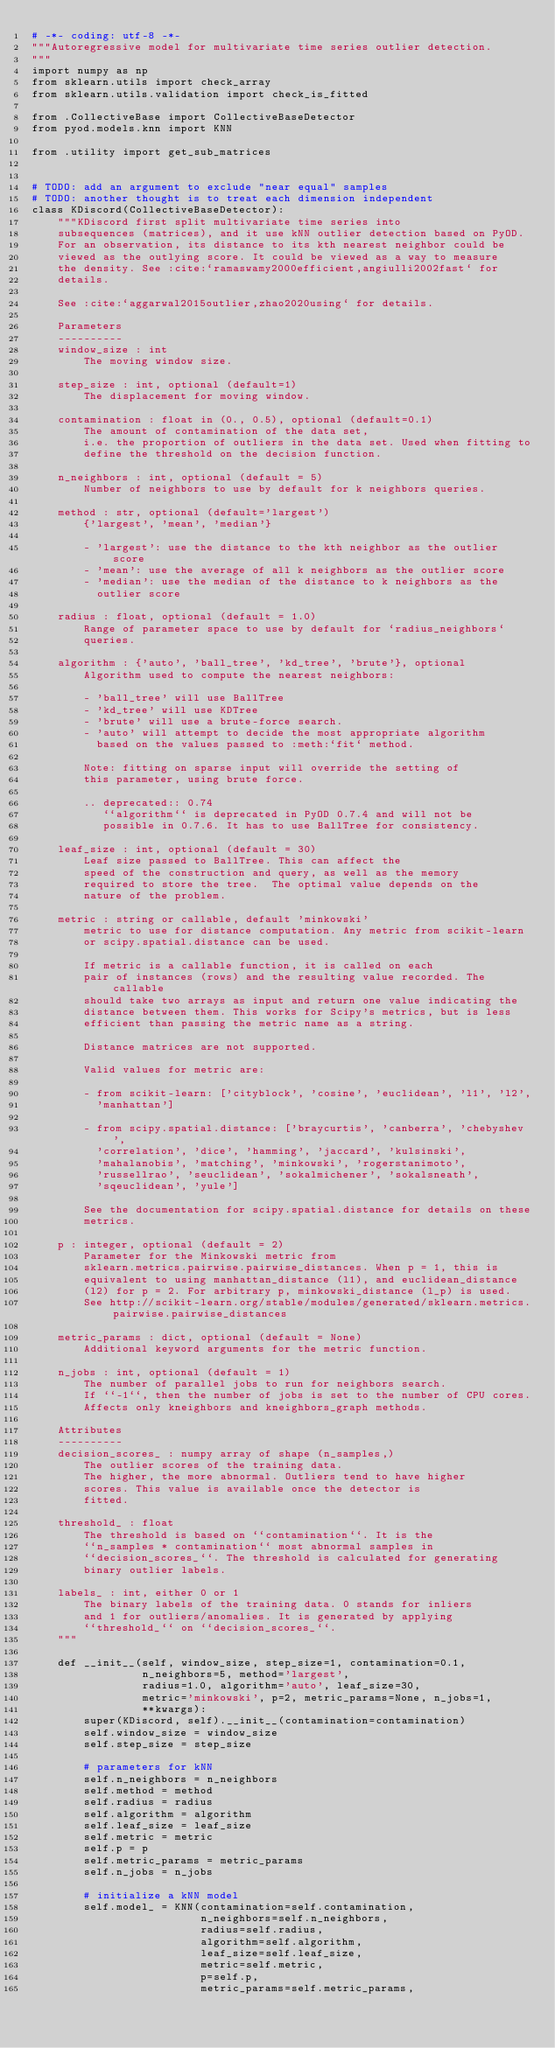Convert code to text. <code><loc_0><loc_0><loc_500><loc_500><_Python_># -*- coding: utf-8 -*-
"""Autoregressive model for multivariate time series outlier detection.
"""
import numpy as np
from sklearn.utils import check_array
from sklearn.utils.validation import check_is_fitted

from .CollectiveBase import CollectiveBaseDetector
from pyod.models.knn import KNN

from .utility import get_sub_matrices


# TODO: add an argument to exclude "near equal" samples
# TODO: another thought is to treat each dimension independent
class KDiscord(CollectiveBaseDetector):
    """KDiscord first split multivariate time series into 
    subsequences (matrices), and it use kNN outlier detection based on PyOD.
    For an observation, its distance to its kth nearest neighbor could be
    viewed as the outlying score. It could be viewed as a way to measure
    the density. See :cite:`ramaswamy2000efficient,angiulli2002fast` for
    details.
    
    See :cite:`aggarwal2015outlier,zhao2020using` for details.

    Parameters
    ----------
    window_size : int
        The moving window size.

    step_size : int, optional (default=1)
        The displacement for moving window.

    contamination : float in (0., 0.5), optional (default=0.1)
        The amount of contamination of the data set,
        i.e. the proportion of outliers in the data set. Used when fitting to
        define the threshold on the decision function.

    n_neighbors : int, optional (default = 5)
        Number of neighbors to use by default for k neighbors queries.

    method : str, optional (default='largest')
        {'largest', 'mean', 'median'}

        - 'largest': use the distance to the kth neighbor as the outlier score
        - 'mean': use the average of all k neighbors as the outlier score
        - 'median': use the median of the distance to k neighbors as the
          outlier score

    radius : float, optional (default = 1.0)
        Range of parameter space to use by default for `radius_neighbors`
        queries.

    algorithm : {'auto', 'ball_tree', 'kd_tree', 'brute'}, optional
        Algorithm used to compute the nearest neighbors:

        - 'ball_tree' will use BallTree
        - 'kd_tree' will use KDTree
        - 'brute' will use a brute-force search.
        - 'auto' will attempt to decide the most appropriate algorithm
          based on the values passed to :meth:`fit` method.

        Note: fitting on sparse input will override the setting of
        this parameter, using brute force.

        .. deprecated:: 0.74
           ``algorithm`` is deprecated in PyOD 0.7.4 and will not be
           possible in 0.7.6. It has to use BallTree for consistency.

    leaf_size : int, optional (default = 30)
        Leaf size passed to BallTree. This can affect the
        speed of the construction and query, as well as the memory
        required to store the tree.  The optimal value depends on the
        nature of the problem.

    metric : string or callable, default 'minkowski'
        metric to use for distance computation. Any metric from scikit-learn
        or scipy.spatial.distance can be used.

        If metric is a callable function, it is called on each
        pair of instances (rows) and the resulting value recorded. The callable
        should take two arrays as input and return one value indicating the
        distance between them. This works for Scipy's metrics, but is less
        efficient than passing the metric name as a string.

        Distance matrices are not supported.

        Valid values for metric are:

        - from scikit-learn: ['cityblock', 'cosine', 'euclidean', 'l1', 'l2',
          'manhattan']

        - from scipy.spatial.distance: ['braycurtis', 'canberra', 'chebyshev',
          'correlation', 'dice', 'hamming', 'jaccard', 'kulsinski',
          'mahalanobis', 'matching', 'minkowski', 'rogerstanimoto',
          'russellrao', 'seuclidean', 'sokalmichener', 'sokalsneath',
          'sqeuclidean', 'yule']

        See the documentation for scipy.spatial.distance for details on these
        metrics.

    p : integer, optional (default = 2)
        Parameter for the Minkowski metric from
        sklearn.metrics.pairwise.pairwise_distances. When p = 1, this is
        equivalent to using manhattan_distance (l1), and euclidean_distance
        (l2) for p = 2. For arbitrary p, minkowski_distance (l_p) is used.
        See http://scikit-learn.org/stable/modules/generated/sklearn.metrics.pairwise.pairwise_distances

    metric_params : dict, optional (default = None)
        Additional keyword arguments for the metric function.

    n_jobs : int, optional (default = 1)
        The number of parallel jobs to run for neighbors search.
        If ``-1``, then the number of jobs is set to the number of CPU cores.
        Affects only kneighbors and kneighbors_graph methods.

    Attributes
    ----------
    decision_scores_ : numpy array of shape (n_samples,)
        The outlier scores of the training data.
        The higher, the more abnormal. Outliers tend to have higher
        scores. This value is available once the detector is
        fitted.

    threshold_ : float
        The threshold is based on ``contamination``. It is the
        ``n_samples * contamination`` most abnormal samples in
        ``decision_scores_``. The threshold is calculated for generating
        binary outlier labels.

    labels_ : int, either 0 or 1
        The binary labels of the training data. 0 stands for inliers
        and 1 for outliers/anomalies. It is generated by applying
        ``threshold_`` on ``decision_scores_``.
    """

    def __init__(self, window_size, step_size=1, contamination=0.1,
                 n_neighbors=5, method='largest',
                 radius=1.0, algorithm='auto', leaf_size=30,
                 metric='minkowski', p=2, metric_params=None, n_jobs=1,
                 **kwargs):
        super(KDiscord, self).__init__(contamination=contamination)
        self.window_size = window_size
        self.step_size = step_size

        # parameters for kNN
        self.n_neighbors = n_neighbors
        self.method = method
        self.radius = radius
        self.algorithm = algorithm
        self.leaf_size = leaf_size
        self.metric = metric
        self.p = p
        self.metric_params = metric_params
        self.n_jobs = n_jobs

        # initialize a kNN model
        self.model_ = KNN(contamination=self.contamination,
                          n_neighbors=self.n_neighbors,
                          radius=self.radius,
                          algorithm=self.algorithm,
                          leaf_size=self.leaf_size,
                          metric=self.metric,
                          p=self.p,
                          metric_params=self.metric_params,</code> 